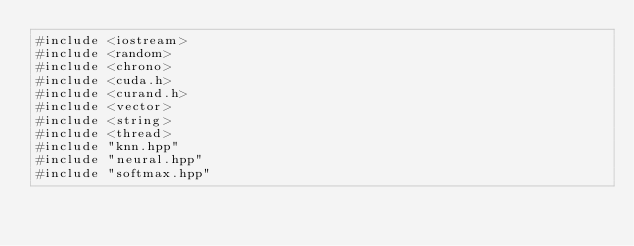Convert code to text. <code><loc_0><loc_0><loc_500><loc_500><_Cuda_>#include <iostream>
#include <random>
#include <chrono>
#include <cuda.h>
#include <curand.h>
#include <vector>
#include <string>
#include <thread>
#include "knn.hpp"
#include "neural.hpp"
#include "softmax.hpp"
</code> 